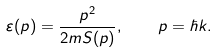Convert formula to latex. <formula><loc_0><loc_0><loc_500><loc_500>\varepsilon ( p ) = \frac { p ^ { 2 } } { 2 m S ( p ) } , \quad p = \hbar { k } .</formula> 